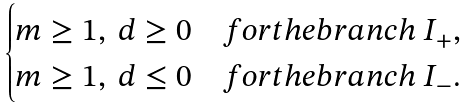<formula> <loc_0><loc_0><loc_500><loc_500>\begin{cases} m \geq 1 , \ d \geq 0 & f o r t h e b r a n c h \ I _ { + } , \\ m \geq 1 , \ d \leq 0 & f o r t h e b r a n c h \ I _ { - } . \end{cases}</formula> 